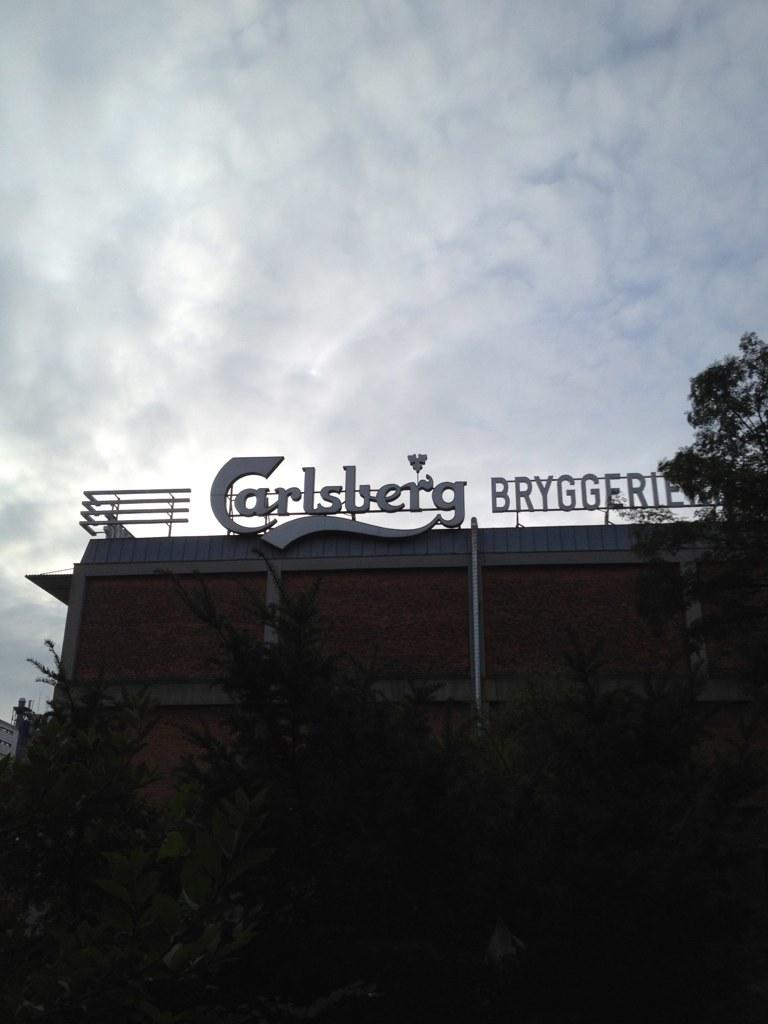What type of structure is present in the image? There is a building in the image. What is attached to the building in the image? There is a hoarding in the image. What type of vegetation can be seen in the image? There are trees in the image. What other object can be seen in the image? There is a pole in the image. How would you describe the weather in the image? The sky is cloudy in the image. What type of scent can be detected in the room depicted in the image? There is no room depicted in the image, as it is an outdoor scene featuring a building, hoarding, trees, pole, and cloudy sky. 